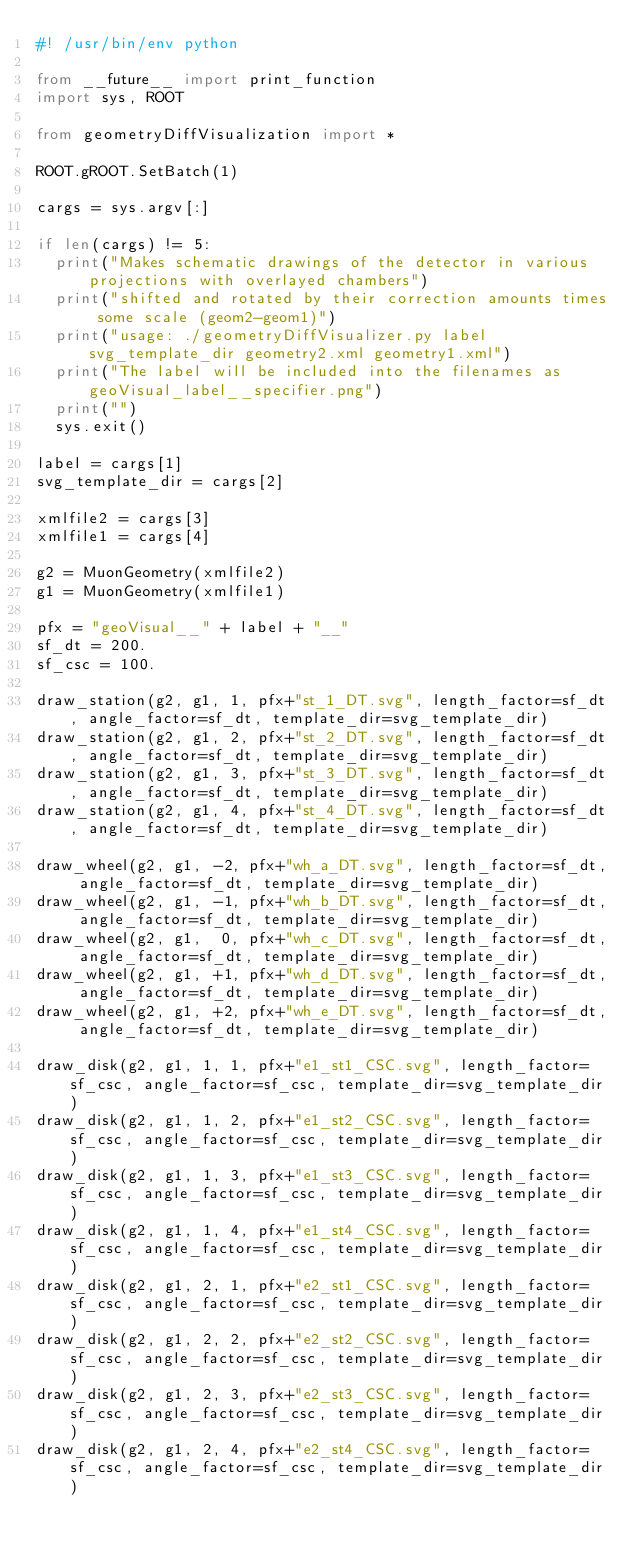<code> <loc_0><loc_0><loc_500><loc_500><_Python_>#! /usr/bin/env python

from __future__ import print_function
import sys, ROOT

from geometryDiffVisualization import *

ROOT.gROOT.SetBatch(1)

cargs = sys.argv[:]

if len(cargs) != 5:
  print("Makes schematic drawings of the detector in various projections with overlayed chambers")
  print("shifted and rotated by their correction amounts times some scale (geom2-geom1)")
  print("usage: ./geometryDiffVisualizer.py label svg_template_dir geometry2.xml geometry1.xml")
  print("The label will be included into the filenames as geoVisual_label__specifier.png")
  print("")
  sys.exit()

label = cargs[1]
svg_template_dir = cargs[2]

xmlfile2 = cargs[3]
xmlfile1 = cargs[4]

g2 = MuonGeometry(xmlfile2)
g1 = MuonGeometry(xmlfile1)

pfx = "geoVisual__" + label + "__"
sf_dt = 200.
sf_csc = 100.

draw_station(g2, g1, 1, pfx+"st_1_DT.svg", length_factor=sf_dt, angle_factor=sf_dt, template_dir=svg_template_dir)
draw_station(g2, g1, 2, pfx+"st_2_DT.svg", length_factor=sf_dt, angle_factor=sf_dt, template_dir=svg_template_dir)
draw_station(g2, g1, 3, pfx+"st_3_DT.svg", length_factor=sf_dt, angle_factor=sf_dt, template_dir=svg_template_dir)
draw_station(g2, g1, 4, pfx+"st_4_DT.svg", length_factor=sf_dt, angle_factor=sf_dt, template_dir=svg_template_dir)

draw_wheel(g2, g1, -2, pfx+"wh_a_DT.svg", length_factor=sf_dt, angle_factor=sf_dt, template_dir=svg_template_dir)
draw_wheel(g2, g1, -1, pfx+"wh_b_DT.svg", length_factor=sf_dt, angle_factor=sf_dt, template_dir=svg_template_dir)
draw_wheel(g2, g1,  0, pfx+"wh_c_DT.svg", length_factor=sf_dt, angle_factor=sf_dt, template_dir=svg_template_dir)
draw_wheel(g2, g1, +1, pfx+"wh_d_DT.svg", length_factor=sf_dt, angle_factor=sf_dt, template_dir=svg_template_dir)
draw_wheel(g2, g1, +2, pfx+"wh_e_DT.svg", length_factor=sf_dt, angle_factor=sf_dt, template_dir=svg_template_dir)

draw_disk(g2, g1, 1, 1, pfx+"e1_st1_CSC.svg", length_factor=sf_csc, angle_factor=sf_csc, template_dir=svg_template_dir)
draw_disk(g2, g1, 1, 2, pfx+"e1_st2_CSC.svg", length_factor=sf_csc, angle_factor=sf_csc, template_dir=svg_template_dir)
draw_disk(g2, g1, 1, 3, pfx+"e1_st3_CSC.svg", length_factor=sf_csc, angle_factor=sf_csc, template_dir=svg_template_dir)
draw_disk(g2, g1, 1, 4, pfx+"e1_st4_CSC.svg", length_factor=sf_csc, angle_factor=sf_csc, template_dir=svg_template_dir)
draw_disk(g2, g1, 2, 1, pfx+"e2_st1_CSC.svg", length_factor=sf_csc, angle_factor=sf_csc, template_dir=svg_template_dir)
draw_disk(g2, g1, 2, 2, pfx+"e2_st2_CSC.svg", length_factor=sf_csc, angle_factor=sf_csc, template_dir=svg_template_dir)
draw_disk(g2, g1, 2, 3, pfx+"e2_st3_CSC.svg", length_factor=sf_csc, angle_factor=sf_csc, template_dir=svg_template_dir)
draw_disk(g2, g1, 2, 4, pfx+"e2_st4_CSC.svg", length_factor=sf_csc, angle_factor=sf_csc, template_dir=svg_template_dir)
</code> 